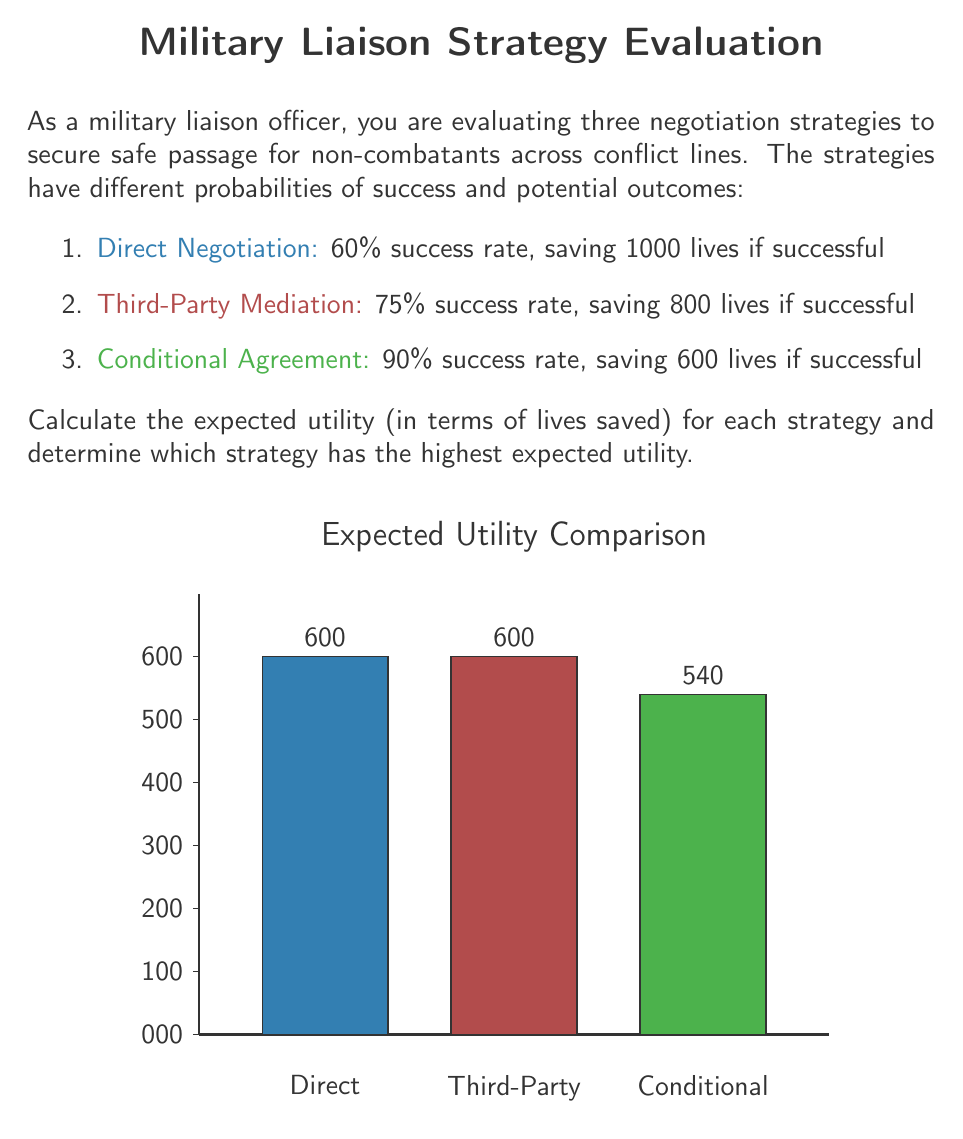What is the answer to this math problem? To solve this problem, we need to calculate the expected utility for each strategy using the formula:

Expected Utility = Probability of Success × Lives Saved if Successful

Let's calculate for each strategy:

1. Direct Negotiation:
   $$ E(U_{direct}) = 0.60 \times 1000 = 600 $$

2. Third-Party Mediation:
   $$ E(U_{third-party}) = 0.75 \times 800 = 600 $$

3. Conditional Agreement:
   $$ E(U_{conditional}) = 0.90 \times 600 = 540 $$

Now, let's compare the expected utilities:

- Direct Negotiation: 600 lives
- Third-Party Mediation: 600 lives
- Conditional Agreement: 540 lives

We can see that both Direct Negotiation and Third-Party Mediation have the highest expected utility of 600 lives saved.

The Conditional Agreement strategy, despite having the highest success rate, has a lower expected utility due to the smaller number of lives potentially saved.

Therefore, from a decision theory perspective, both Direct Negotiation and Third-Party Mediation are equally optimal strategies, as they maximize the expected utility in terms of lives saved.
Answer: Direct Negotiation and Third-Party Mediation (tie); 600 lives 